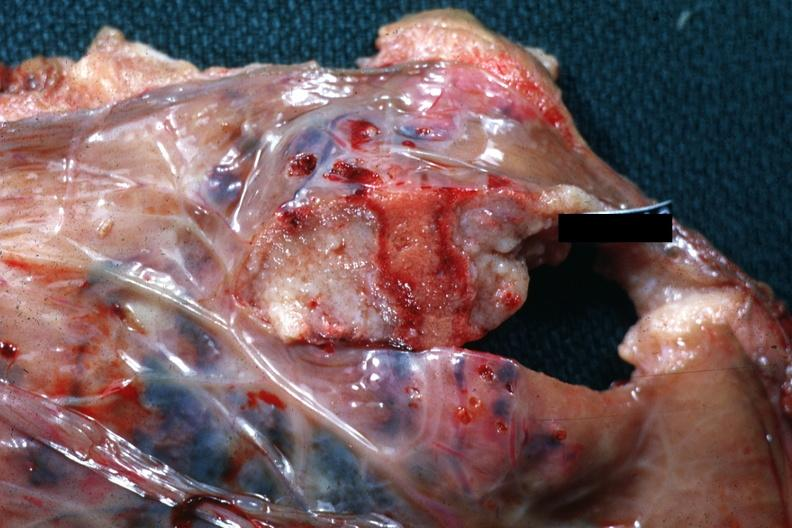does this image show good close-up of needle tract with necrotic center?
Answer the question using a single word or phrase. Yes 